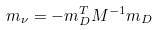<formula> <loc_0><loc_0><loc_500><loc_500>m _ { \nu } = - m _ { D } ^ { T } M ^ { - 1 } m _ { D }</formula> 